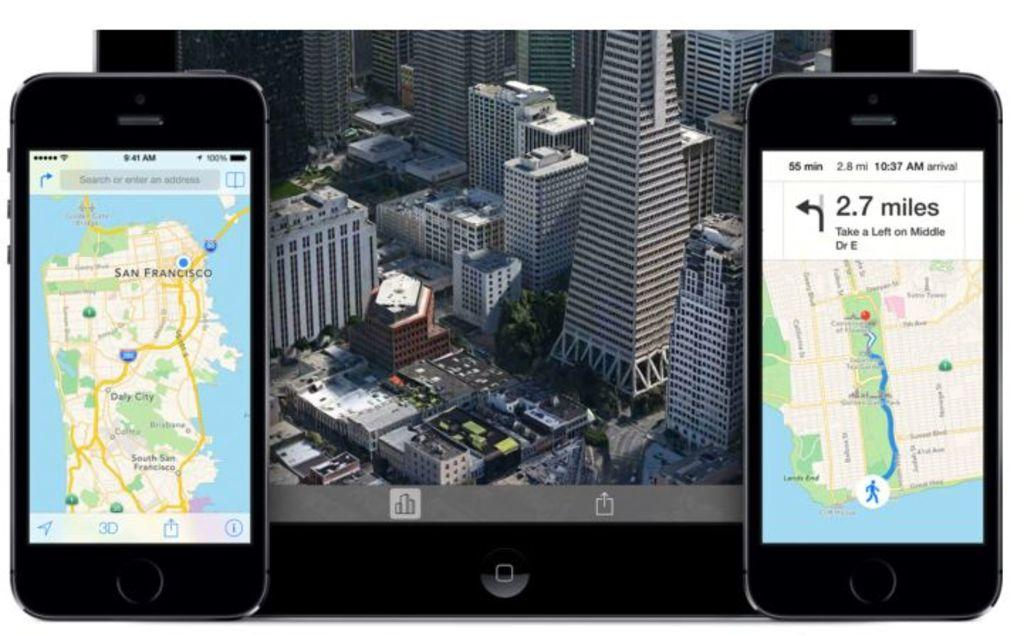<image>
Create a compact narrative representing the image presented. Two phones next to an iPad with one phone saying 2.7 miles. 